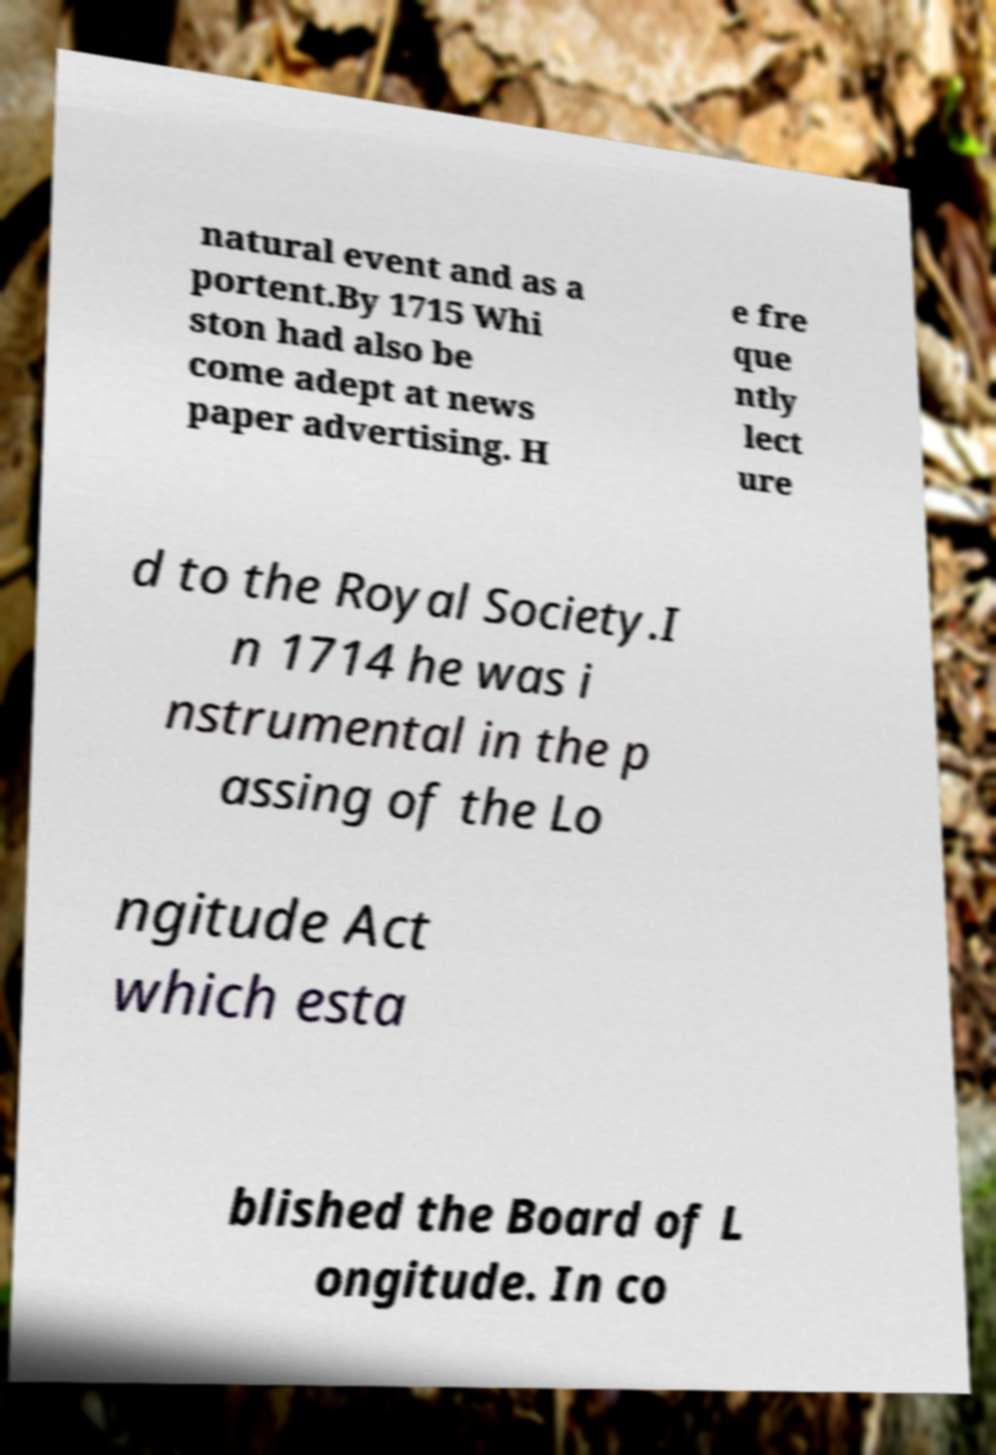Can you accurately transcribe the text from the provided image for me? natural event and as a portent.By 1715 Whi ston had also be come adept at news paper advertising. H e fre que ntly lect ure d to the Royal Society.I n 1714 he was i nstrumental in the p assing of the Lo ngitude Act which esta blished the Board of L ongitude. In co 